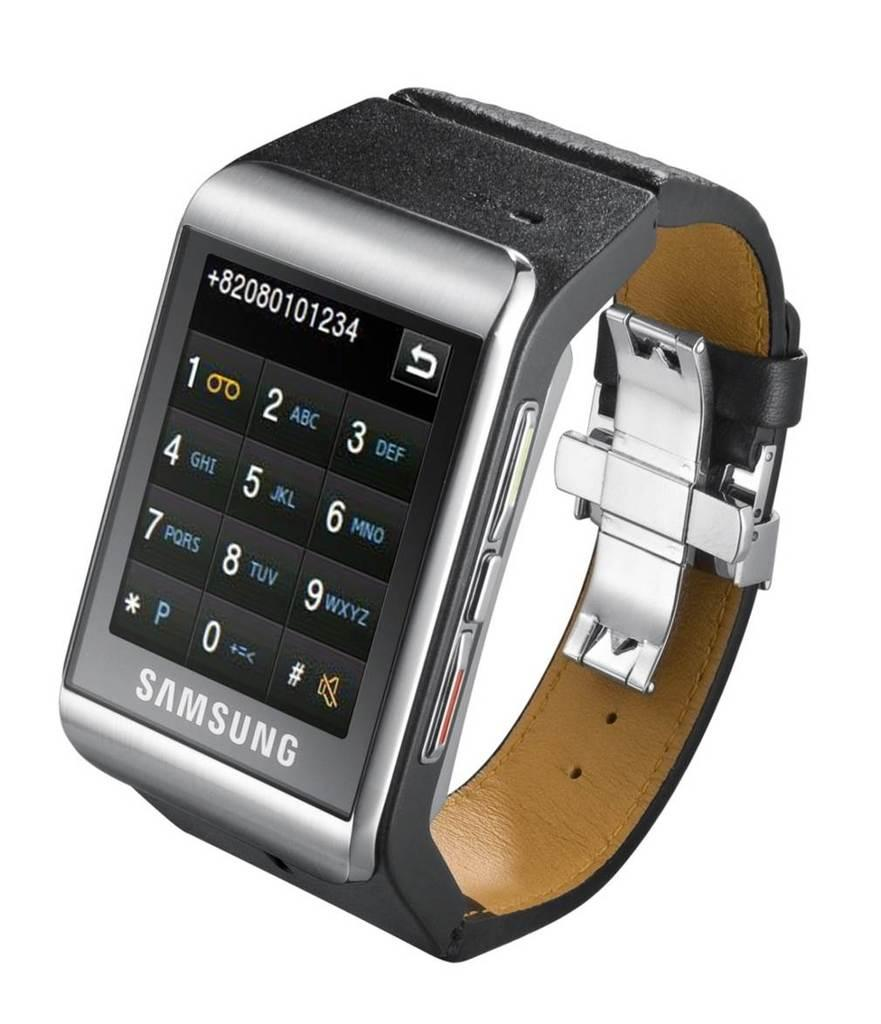<image>
Summarize the visual content of the image. A Samsung smart watch shows a phone number on the display. 